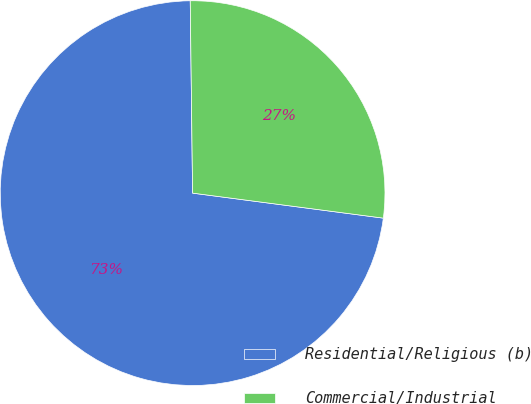Convert chart. <chart><loc_0><loc_0><loc_500><loc_500><pie_chart><fcel>Residential/Religious (b)<fcel>Commercial/Industrial<nl><fcel>72.73%<fcel>27.27%<nl></chart> 